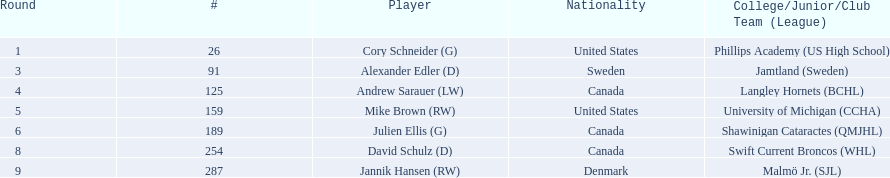What nationalities do the players have? United States, Sweden, Canada, United States, Canada, Canada, Denmark. Among the players, who has danish nationality? Jannik Hansen (RW). 